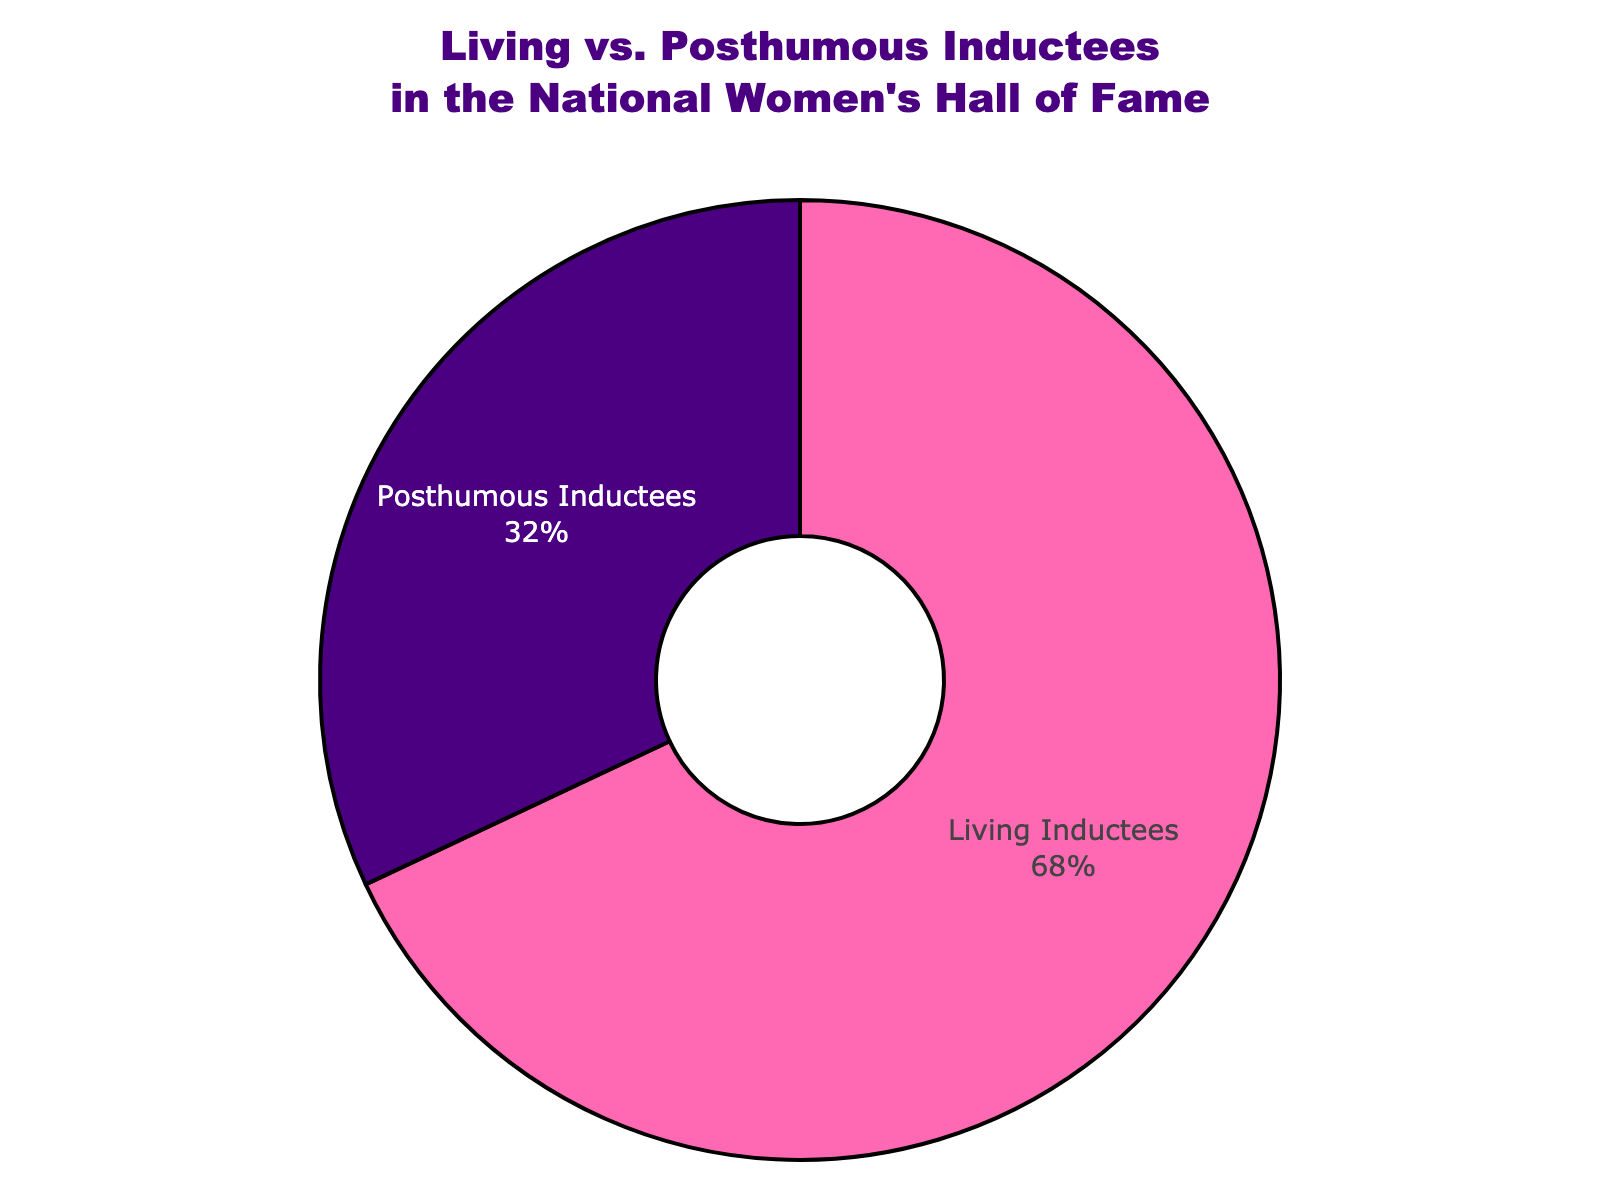What percentage of inductees are living? From the figure, the percentage shown for living inductees is 68%.
Answer: 68% Which group has a higher percentage, living inductees or posthumous inductees? According to the figure, living inductees represent 68% while posthumous inductees represent 32%, so living inductees have a higher percentage.
Answer: Living inductees What is the difference in percentage between living and posthumous inductees? The percentage for living inductees is 68%, and for posthumous inductees, it is 32%. The difference is 68% - 32%.
Answer: 36% What fraction of the total inductees are posthumous? The percentage of posthumous inductees is 32%. To convert this percentage to a fraction, divide by 100: 32/100 = 0.32. Simplifying 0.32 gives the fraction.
Answer: 0.32 How would you describe the color representation for each group in the chart? Living inductees are represented by a pink section of the pie chart, while posthumous inductees are represented by an indigo section.
Answer: Pink for living, indigo for posthumous Is the percentage of living inductees greater than twice the percentage of posthumous inductees? Twice the percentage of posthumous inductees is 2 * 32% = 64%. The percentage of living inductees is 68%, which is indeed greater than 64%.
Answer: Yes What proportion of the inductees are living compared to the total number of inductees? The living inductees make up 68% of the total inductees. To express this as a proportion: 68/100, which simplifies to 0.68.
Answer: 0.68 If there are 100 total inductees, how many are living and how many are posthumous? 68% of 100 inductees are living, which is 68, and 32% are posthumous, which is 32.
Answer: 68 living, 32 posthumous What does the black outline around each segment represent in the figure? The black outline is a visual attribute used to clearly delineate each section of the pie chart, making it easier to see the separation between the two groups.
Answer: Separation outline What overall insight can you gather from comparing the two groups of inductees in the pie chart? The pie chart visually conveys that a majority of the inductees in the National Women's Hall of Fame are living, comprising 68% of the total, while 32% are posthumous, indicating a significant representation of current contributions.
Answer: Majority living inductees 